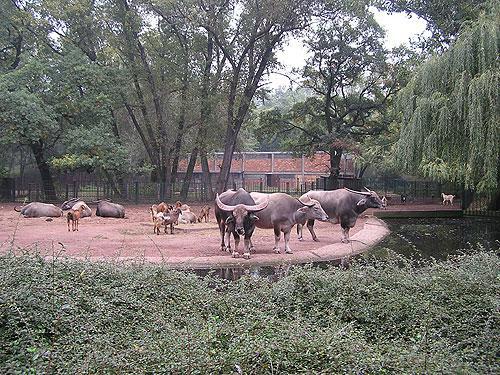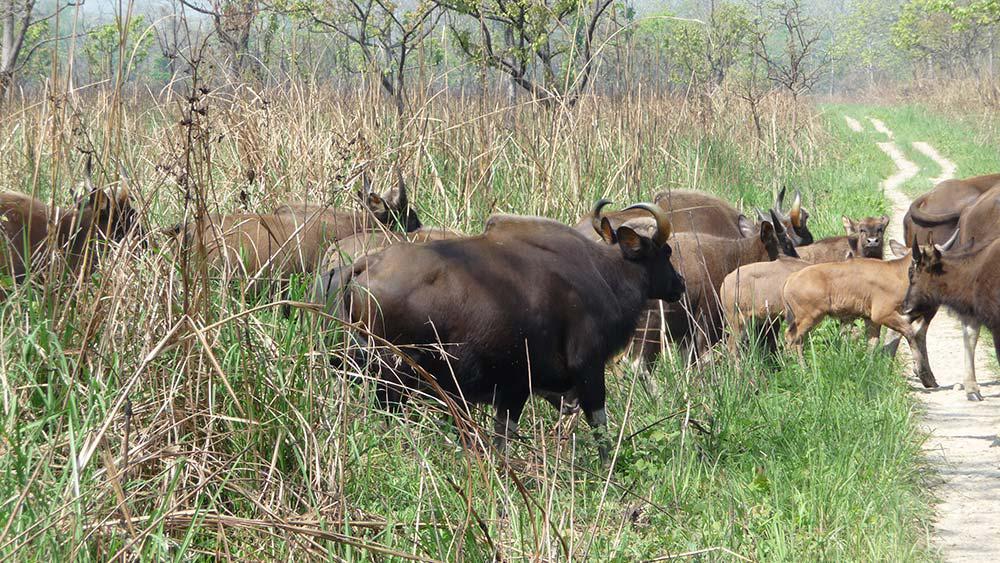The first image is the image on the left, the second image is the image on the right. Analyze the images presented: Is the assertion "At least one animal is in the water in the image on the right." valid? Answer yes or no. No. 